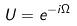<formula> <loc_0><loc_0><loc_500><loc_500>U = e ^ { - i \Omega }</formula> 